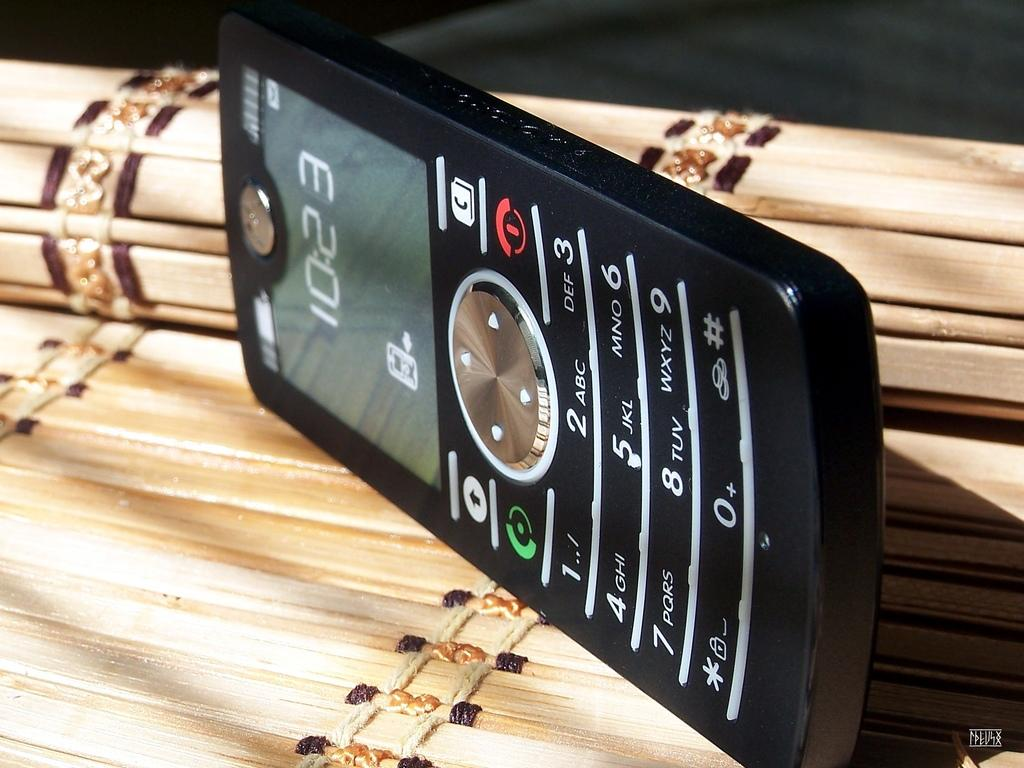<image>
Provide a brief description of the given image. The time shown on the mobile phone is 10:23 